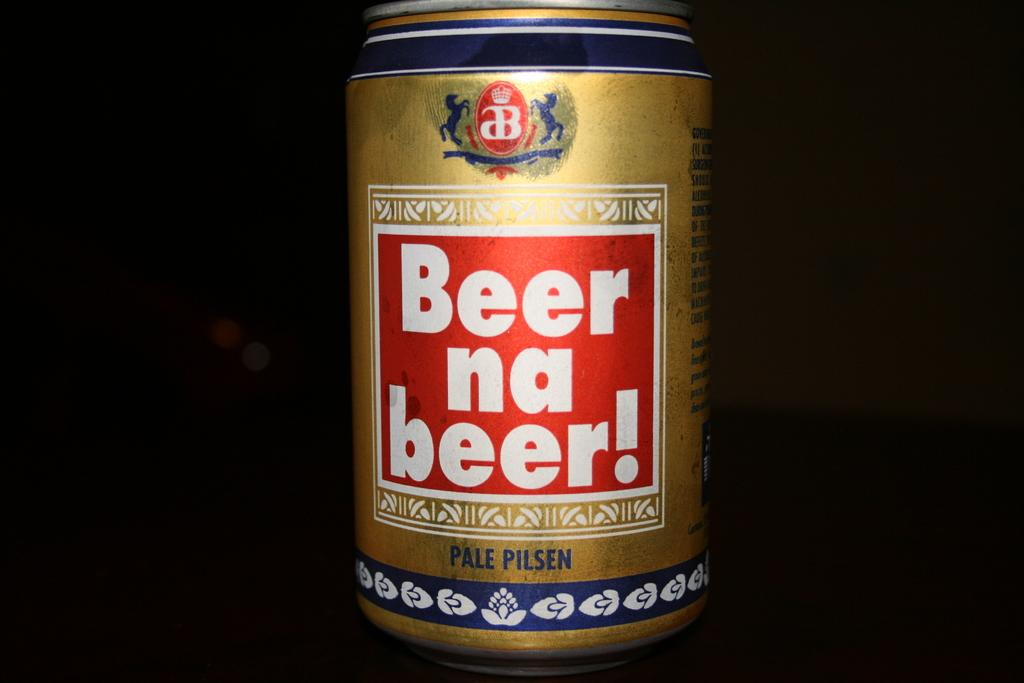<image>
Relay a brief, clear account of the picture shown. A gold beer can is show against a black background. 